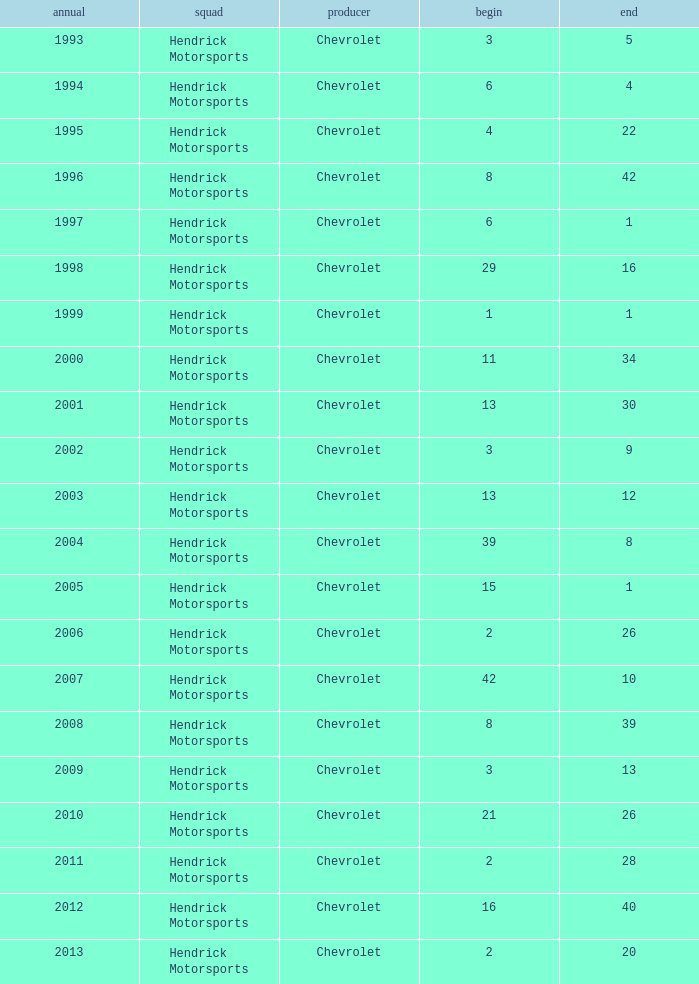What was Jeff's finish in 2011? 28.0. 